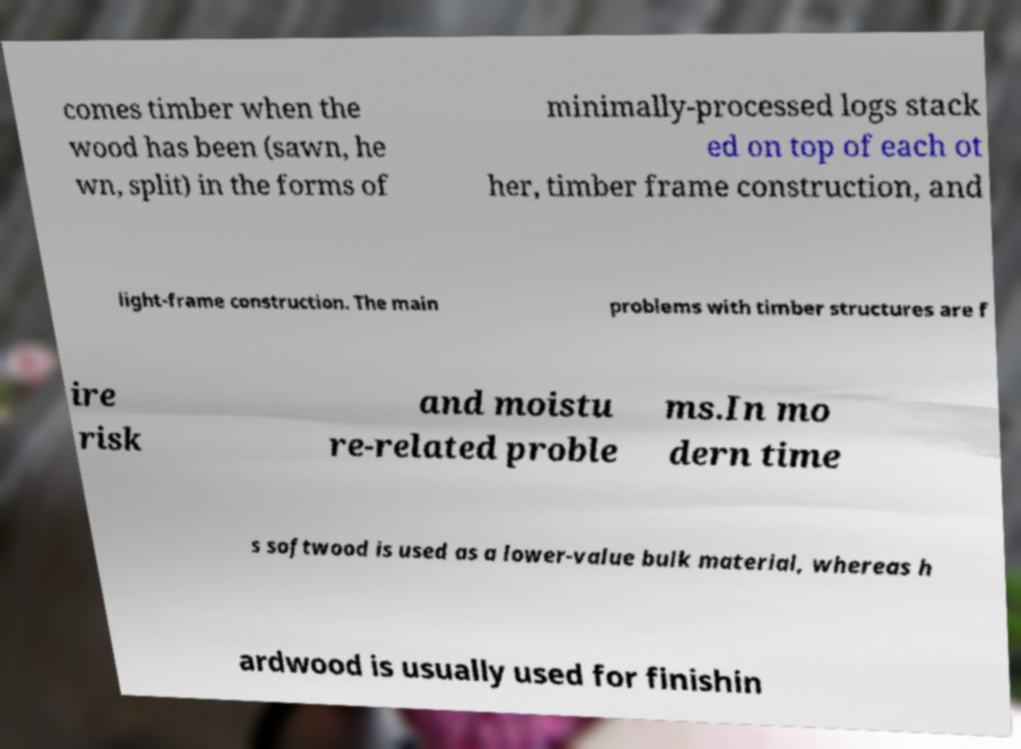Please identify and transcribe the text found in this image. comes timber when the wood has been (sawn, he wn, split) in the forms of minimally-processed logs stack ed on top of each ot her, timber frame construction, and light-frame construction. The main problems with timber structures are f ire risk and moistu re-related proble ms.In mo dern time s softwood is used as a lower-value bulk material, whereas h ardwood is usually used for finishin 